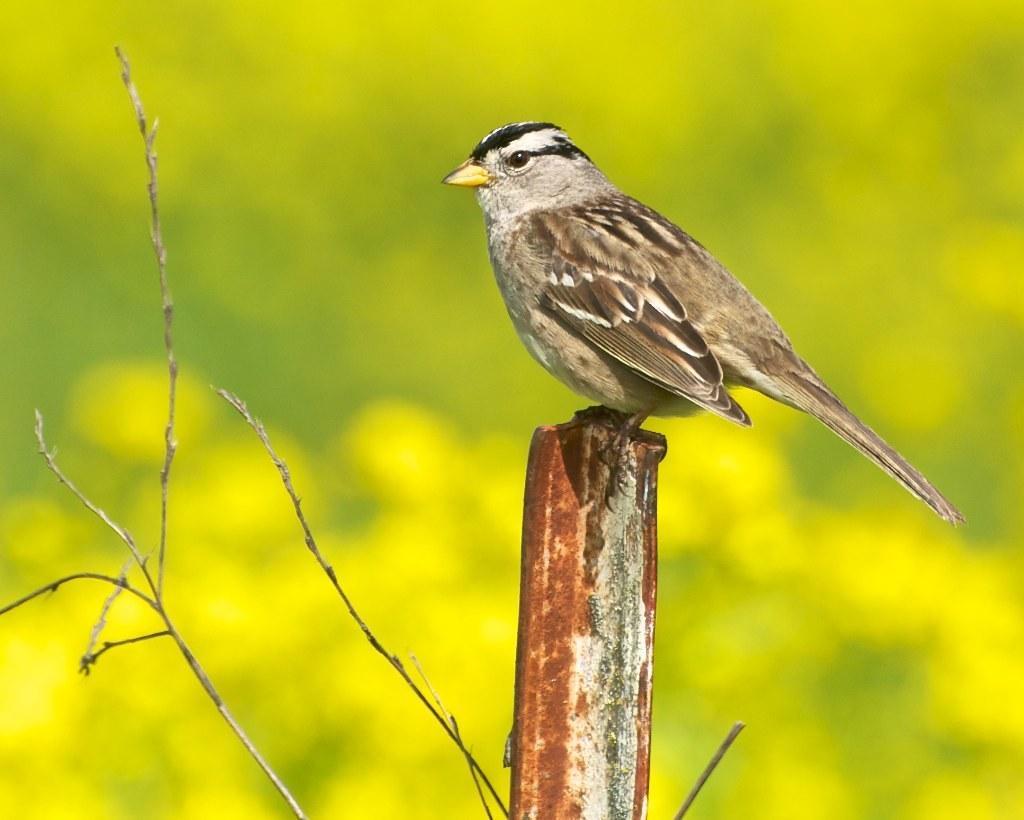Please provide a concise description of this image. In this image we can see a sparrow, it is in brown color, here is the eye, here is the tail, the background is blurry. 